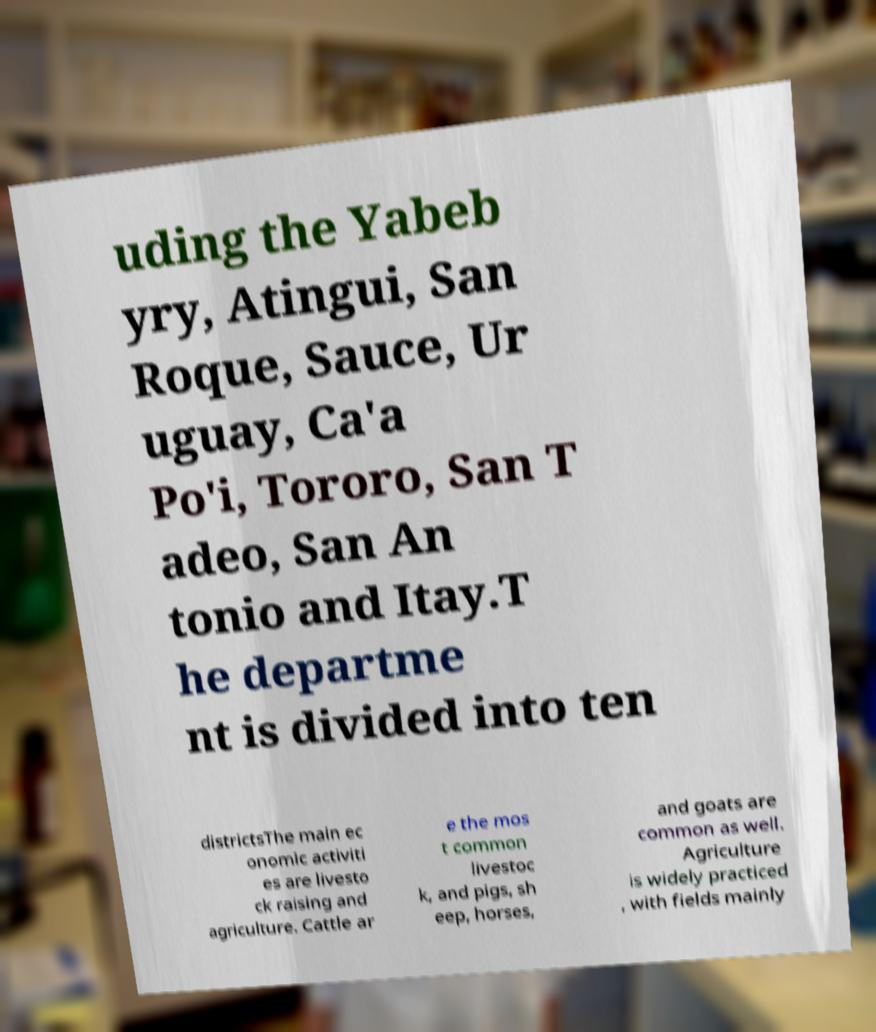Can you accurately transcribe the text from the provided image for me? uding the Yabeb yry, Atingui, San Roque, Sauce, Ur uguay, Ca'a Po'i, Tororo, San T adeo, San An tonio and Itay.T he departme nt is divided into ten districtsThe main ec onomic activiti es are livesto ck raising and agriculture. Cattle ar e the mos t common livestoc k, and pigs, sh eep, horses, and goats are common as well. Agriculture is widely practiced , with fields mainly 